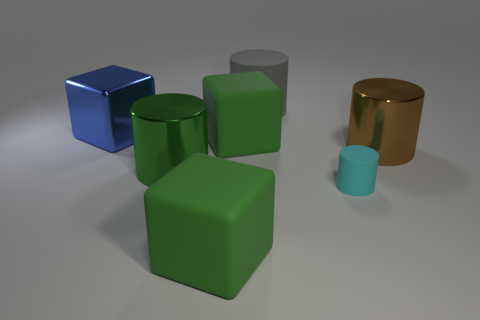How big is the metal thing behind the large green rubber block that is behind the matte cylinder right of the big rubber cylinder?
Make the answer very short. Large. What number of other things are the same size as the cyan cylinder?
Ensure brevity in your answer.  0. Is the color of the tiny cylinder the same as the large rubber cylinder?
Provide a short and direct response. No. What is the color of the metallic object in front of the large cylinder to the right of the gray matte object on the right side of the big blue cube?
Provide a short and direct response. Green. There is a green rubber thing behind the large rubber cube in front of the small matte cylinder; how many cylinders are left of it?
Keep it short and to the point. 1. Is there anything else that has the same color as the tiny matte cylinder?
Provide a short and direct response. No. There is a object that is behind the blue metal thing; is it the same size as the brown cylinder?
Your response must be concise. Yes. How many green cubes are behind the metal cylinder to the right of the tiny cylinder?
Make the answer very short. 1. Is there a small cyan rubber object to the left of the green rubber object that is on the left side of the green matte block that is behind the cyan matte cylinder?
Give a very brief answer. No. There is another green thing that is the same shape as the small rubber thing; what material is it?
Give a very brief answer. Metal. 